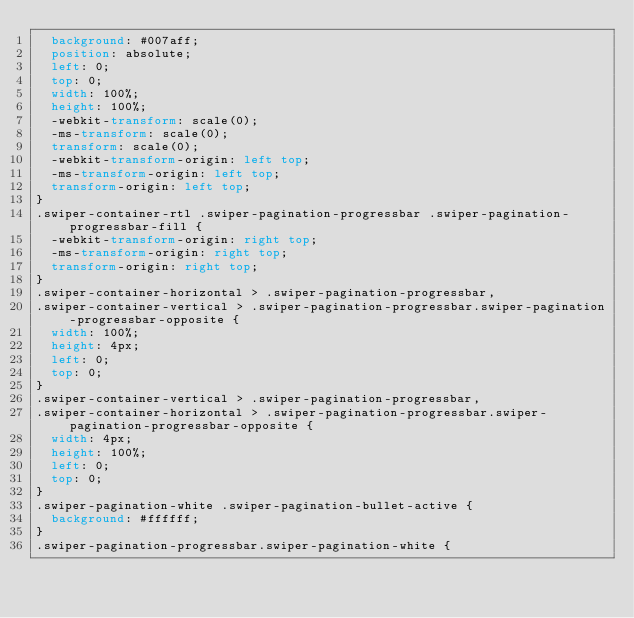<code> <loc_0><loc_0><loc_500><loc_500><_CSS_>  background: #007aff;
  position: absolute;
  left: 0;
  top: 0;
  width: 100%;
  height: 100%;
  -webkit-transform: scale(0);
  -ms-transform: scale(0);
  transform: scale(0);
  -webkit-transform-origin: left top;
  -ms-transform-origin: left top;
  transform-origin: left top;
}
.swiper-container-rtl .swiper-pagination-progressbar .swiper-pagination-progressbar-fill {
  -webkit-transform-origin: right top;
  -ms-transform-origin: right top;
  transform-origin: right top;
}
.swiper-container-horizontal > .swiper-pagination-progressbar,
.swiper-container-vertical > .swiper-pagination-progressbar.swiper-pagination-progressbar-opposite {
  width: 100%;
  height: 4px;
  left: 0;
  top: 0;
}
.swiper-container-vertical > .swiper-pagination-progressbar,
.swiper-container-horizontal > .swiper-pagination-progressbar.swiper-pagination-progressbar-opposite {
  width: 4px;
  height: 100%;
  left: 0;
  top: 0;
}
.swiper-pagination-white .swiper-pagination-bullet-active {
  background: #ffffff;
}
.swiper-pagination-progressbar.swiper-pagination-white {</code> 